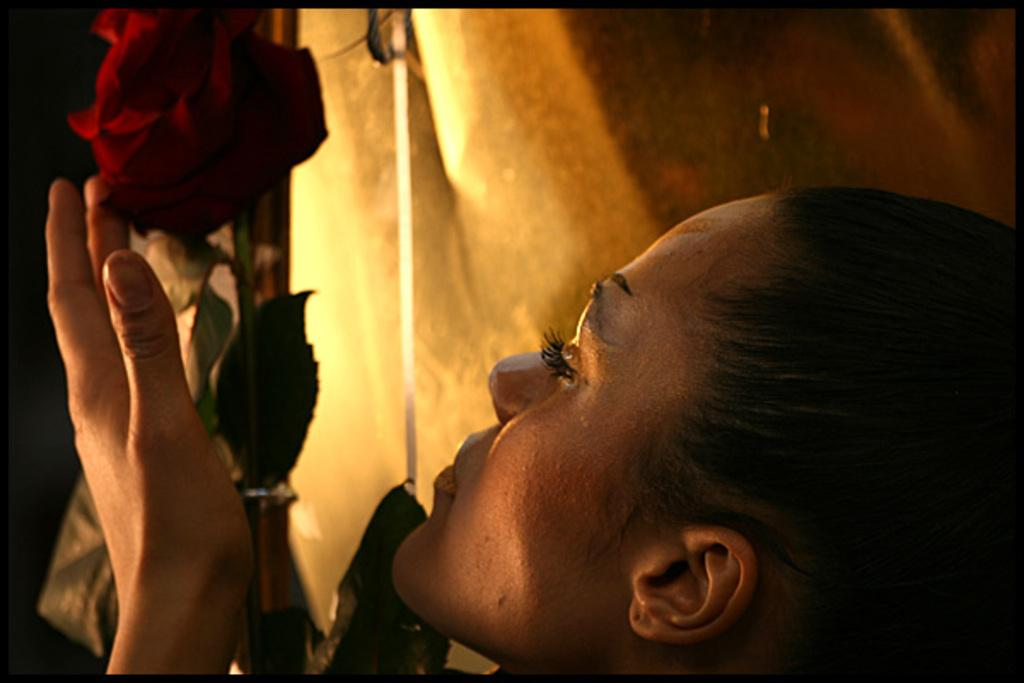Who is the main subject in the image? There is a woman in the image. What is the woman holding in the image? The woman is holding a rose. What type of writer is the woman in the image? There is no indication in the image that the woman is a writer, as she is holding a rose and no writing materials are visible. 